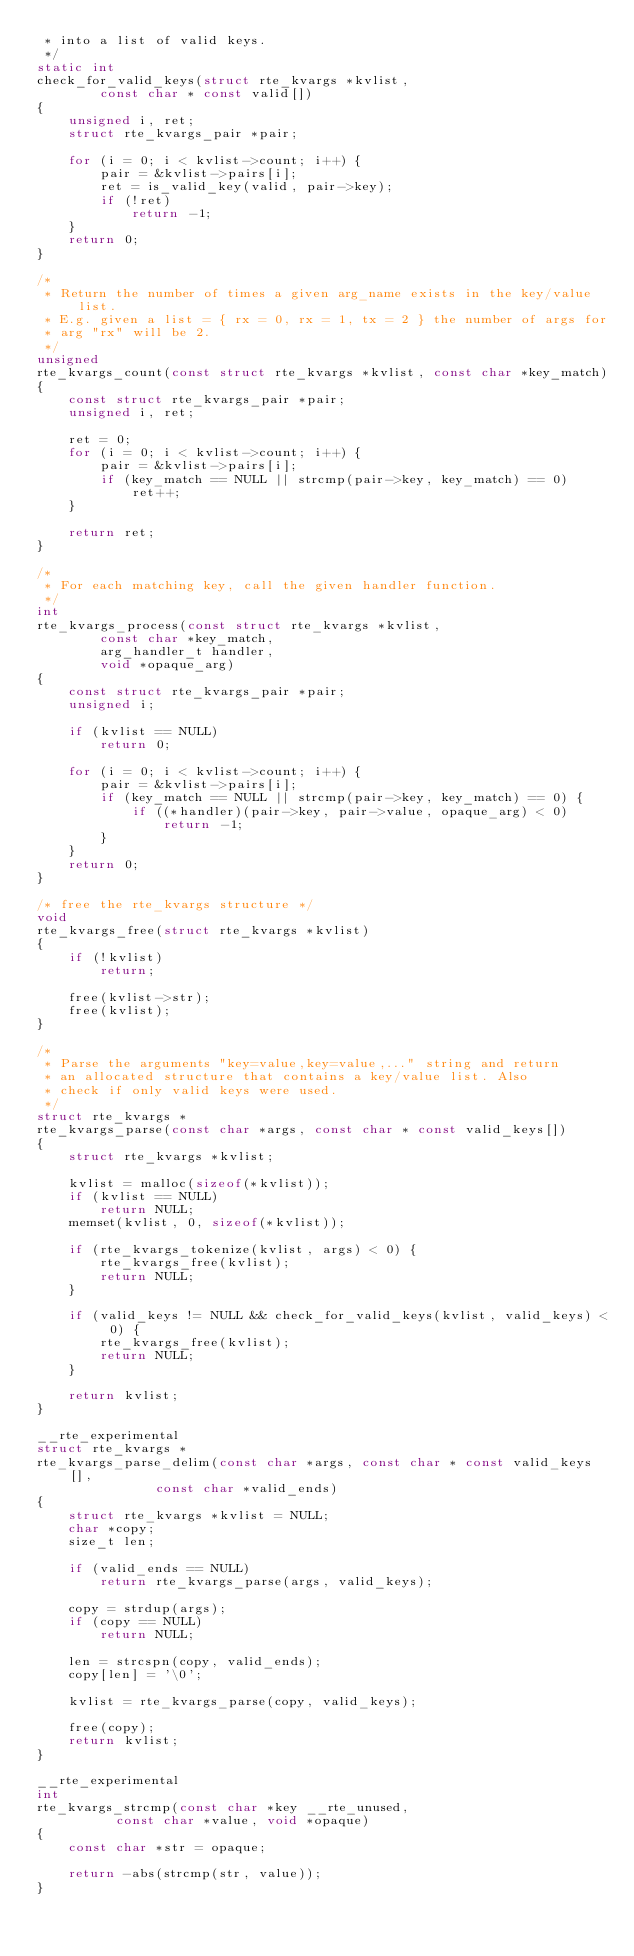Convert code to text. <code><loc_0><loc_0><loc_500><loc_500><_C_> * into a list of valid keys.
 */
static int
check_for_valid_keys(struct rte_kvargs *kvlist,
		const char * const valid[])
{
	unsigned i, ret;
	struct rte_kvargs_pair *pair;

	for (i = 0; i < kvlist->count; i++) {
		pair = &kvlist->pairs[i];
		ret = is_valid_key(valid, pair->key);
		if (!ret)
			return -1;
	}
	return 0;
}

/*
 * Return the number of times a given arg_name exists in the key/value list.
 * E.g. given a list = { rx = 0, rx = 1, tx = 2 } the number of args for
 * arg "rx" will be 2.
 */
unsigned
rte_kvargs_count(const struct rte_kvargs *kvlist, const char *key_match)
{
	const struct rte_kvargs_pair *pair;
	unsigned i, ret;

	ret = 0;
	for (i = 0; i < kvlist->count; i++) {
		pair = &kvlist->pairs[i];
		if (key_match == NULL || strcmp(pair->key, key_match) == 0)
			ret++;
	}

	return ret;
}

/*
 * For each matching key, call the given handler function.
 */
int
rte_kvargs_process(const struct rte_kvargs *kvlist,
		const char *key_match,
		arg_handler_t handler,
		void *opaque_arg)
{
	const struct rte_kvargs_pair *pair;
	unsigned i;

	if (kvlist == NULL)
		return 0;

	for (i = 0; i < kvlist->count; i++) {
		pair = &kvlist->pairs[i];
		if (key_match == NULL || strcmp(pair->key, key_match) == 0) {
			if ((*handler)(pair->key, pair->value, opaque_arg) < 0)
				return -1;
		}
	}
	return 0;
}

/* free the rte_kvargs structure */
void
rte_kvargs_free(struct rte_kvargs *kvlist)
{
	if (!kvlist)
		return;

	free(kvlist->str);
	free(kvlist);
}

/*
 * Parse the arguments "key=value,key=value,..." string and return
 * an allocated structure that contains a key/value list. Also
 * check if only valid keys were used.
 */
struct rte_kvargs *
rte_kvargs_parse(const char *args, const char * const valid_keys[])
{
	struct rte_kvargs *kvlist;

	kvlist = malloc(sizeof(*kvlist));
	if (kvlist == NULL)
		return NULL;
	memset(kvlist, 0, sizeof(*kvlist));

	if (rte_kvargs_tokenize(kvlist, args) < 0) {
		rte_kvargs_free(kvlist);
		return NULL;
	}

	if (valid_keys != NULL && check_for_valid_keys(kvlist, valid_keys) < 0) {
		rte_kvargs_free(kvlist);
		return NULL;
	}

	return kvlist;
}

__rte_experimental
struct rte_kvargs *
rte_kvargs_parse_delim(const char *args, const char * const valid_keys[],
		       const char *valid_ends)
{
	struct rte_kvargs *kvlist = NULL;
	char *copy;
	size_t len;

	if (valid_ends == NULL)
		return rte_kvargs_parse(args, valid_keys);

	copy = strdup(args);
	if (copy == NULL)
		return NULL;

	len = strcspn(copy, valid_ends);
	copy[len] = '\0';

	kvlist = rte_kvargs_parse(copy, valid_keys);

	free(copy);
	return kvlist;
}

__rte_experimental
int
rte_kvargs_strcmp(const char *key __rte_unused,
		  const char *value, void *opaque)
{
	const char *str = opaque;

	return -abs(strcmp(str, value));
}
</code> 